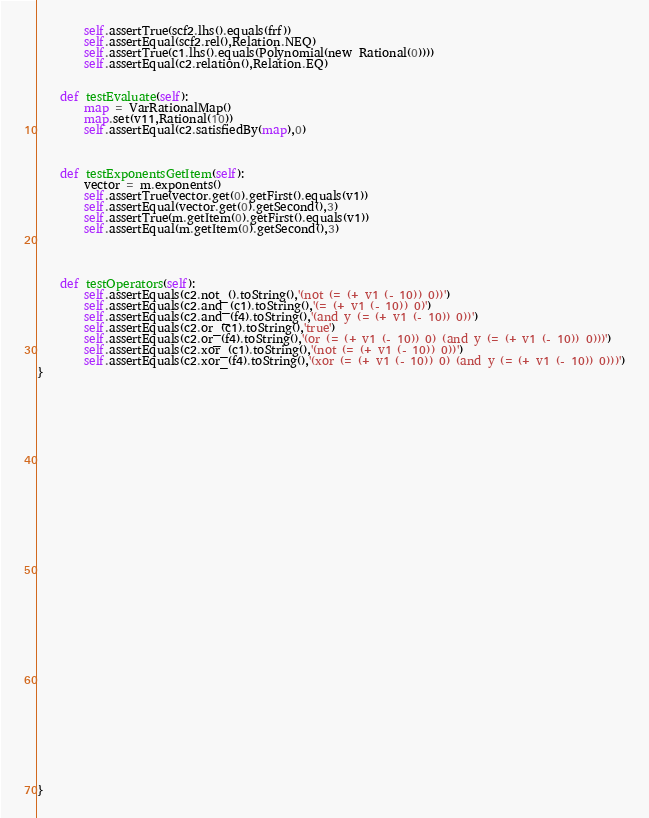Convert code to text. <code><loc_0><loc_0><loc_500><loc_500><_Python_>		self.assertTrue(scf2.lhs().equals(frf))
		self.assertEqual(scf2.rel(),Relation.NEQ)
		self.assertTrue(c1.lhs().equals(Polynomial(new Rational(0))))
		self.assertEqual(c2.relation(),Relation.EQ)


	def testEvaluate(self):
		map = VarRationalMap()
		map.set(v11,Rational(10))
		self.assertEqual(c2.satisfiedBy(map),0)
	


	def testExponentsGetItem(self): 
		vector = m.exponents()
		self.assertTrue(vector.get(0).getFirst().equals(v1))
		self.assertEqual(vector.get(0).getSecond(),3)
		self.assertTrue(m.getItem(0).getFirst().equals(v1))
		self.assertEqual(m.getItem(0).getSecond(),3)
	
	


	def testOperators(self):
		self.assertEquals(c2.not_().toString(),'(not (= (+ v1 (- 10)) 0))')
		self.assertEquals(c2.and_(c1).toString(),'(= (+ v1 (- 10)) 0)')
		self.assertEquals(c2.and_(f4).toString(),'(and y (= (+ v1 (- 10)) 0))')
		self.assertEquals(c2.or_(c1).toString(),'true')
		self.assertEquals(c2.or_(f4).toString(),'(or (= (+ v1 (- 10)) 0) (and y (= (+ v1 (- 10)) 0)))')
		self.assertEquals(c2.xor_(c1).toString(),'(not (= (+ v1 (- 10)) 0))')
		self.assertEquals(c2.xor_(f4).toString(),'(xor (= (+ v1 (- 10)) 0) (and y (= (+ v1 (- 10)) 0)))')
}





































}


</code> 